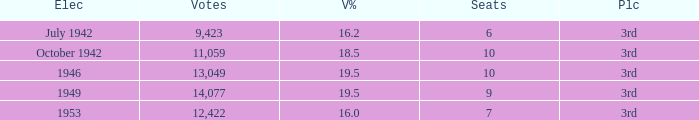Name the total number of seats for votes % more than 19.5 0.0. 